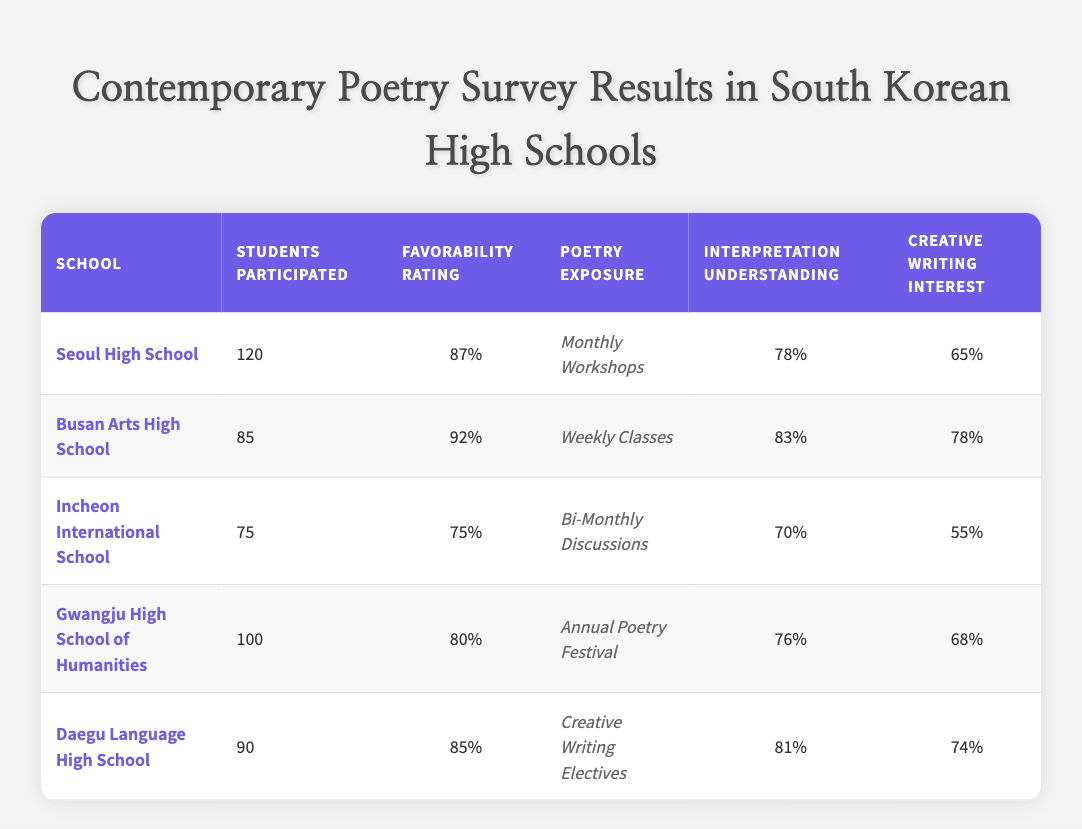What is the favorability rating of Busan Arts High School? The favorability rating for Busan Arts High School is directly listed in the table as 92.
Answer: 92 How many students participated from Gwangju High School of Humanities? The number of students who participated from Gwangju High School of Humanities is shown as 100 in the table.
Answer: 100 Which school has the lowest creative writing interest? The lowest creative writing interest in the table is from Incheon International School, with a rating of 55.
Answer: Incheon International School What is the average interpretation understanding across all schools? The interpretation understanding values are: 78, 83, 70, 76, and 81. Adding these gives a total of 388. There are 5 schools, so the average is 388 divided by 5, which equals 77.6.
Answer: 77.6 Did Daegu Language High School have a higher favorability rating than Gwangju High School of Humanities? Comparing the favorability ratings, Daegu Language High School has 85 and Gwangju High School of Humanities has 80. Since 85 is greater than 80, the statement is true.
Answer: Yes Which school offers poetry exposure through a unique program, such as a festival or an elective? Gwangju High School of Humanities offers exposure through an Annual Poetry Festival, and Daegu Language High School offers Creative Writing Electives. This indicates both schools provide unique poetry exposure programs.
Answer: Gwangju and Daegu If we combine the students participating from Seoul High School and Incheon International School, what is that total? The number of students from Seoul High School is 120, and from Incheon International School, it is 75. Adding these gives a total of 120 + 75 = 195 students.
Answer: 195 Find the difference between the highest and lowest poetry exposure ratings in terms of favorability. The highest favorability rating is from Busan Arts High School at 92, and the lowest is from Incheon International School at 75. Therefore, the difference is 92 - 75 = 17.
Answer: 17 How many schools have a favorability rating above 80? The schools with favorability ratings above 80 are Busan Arts High School (92), Seoul High School (87), and Daegu Language High School (85). This makes a total of 3 schools.
Answer: 3 